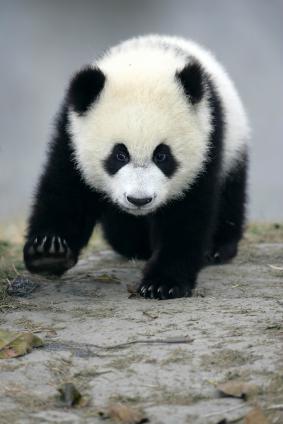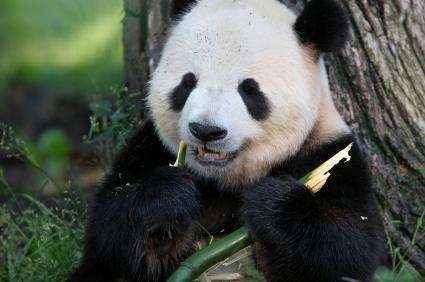The first image is the image on the left, the second image is the image on the right. Assess this claim about the two images: "There are two pandas in one of the pictures.". Correct or not? Answer yes or no. No. 